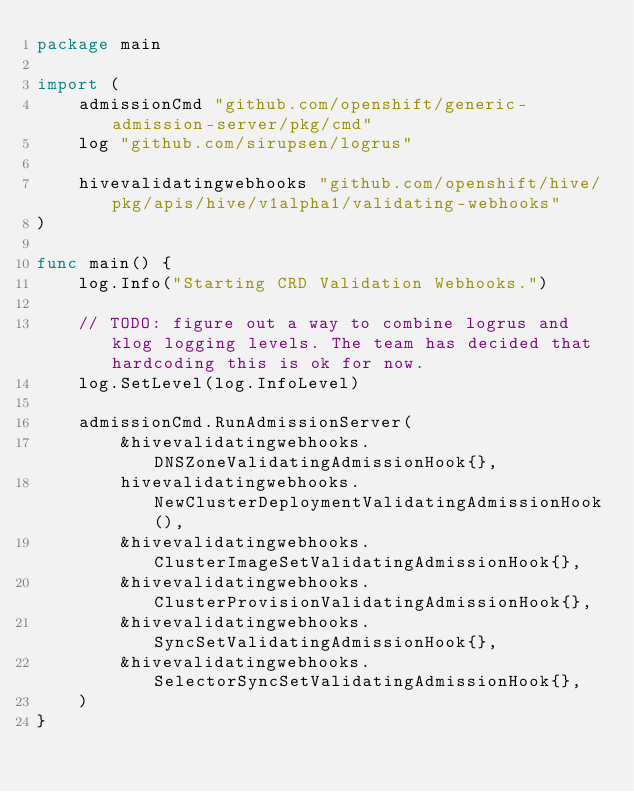Convert code to text. <code><loc_0><loc_0><loc_500><loc_500><_Go_>package main

import (
	admissionCmd "github.com/openshift/generic-admission-server/pkg/cmd"
	log "github.com/sirupsen/logrus"

	hivevalidatingwebhooks "github.com/openshift/hive/pkg/apis/hive/v1alpha1/validating-webhooks"
)

func main() {
	log.Info("Starting CRD Validation Webhooks.")

	// TODO: figure out a way to combine logrus and klog logging levels. The team has decided that hardcoding this is ok for now.
	log.SetLevel(log.InfoLevel)

	admissionCmd.RunAdmissionServer(
		&hivevalidatingwebhooks.DNSZoneValidatingAdmissionHook{},
		hivevalidatingwebhooks.NewClusterDeploymentValidatingAdmissionHook(),
		&hivevalidatingwebhooks.ClusterImageSetValidatingAdmissionHook{},
		&hivevalidatingwebhooks.ClusterProvisionValidatingAdmissionHook{},
		&hivevalidatingwebhooks.SyncSetValidatingAdmissionHook{},
		&hivevalidatingwebhooks.SelectorSyncSetValidatingAdmissionHook{},
	)
}
</code> 